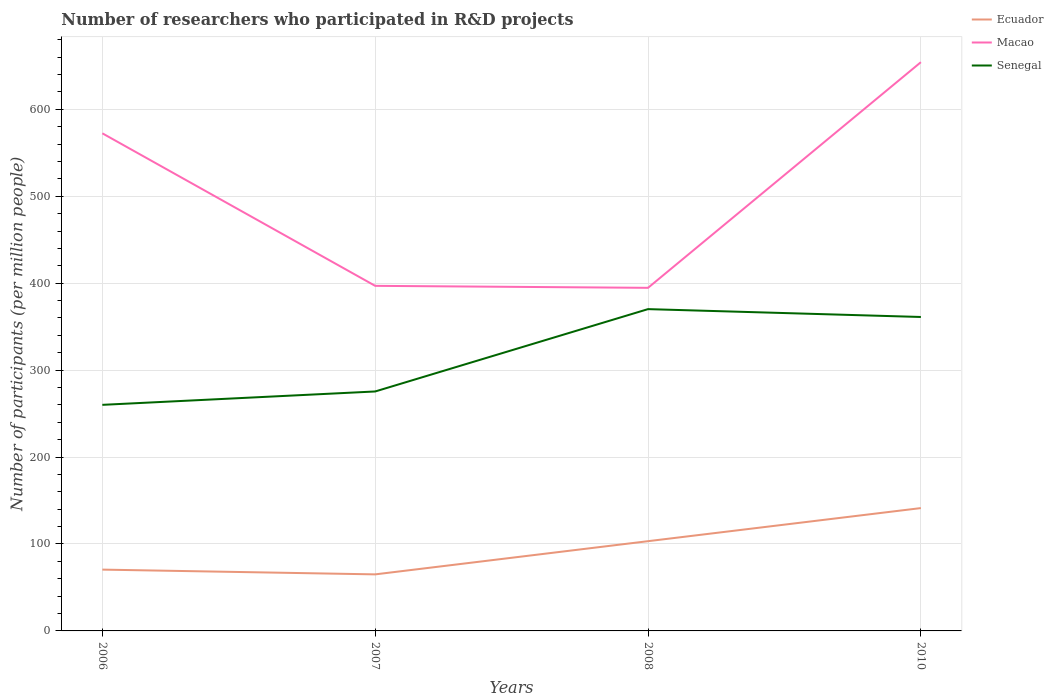How many different coloured lines are there?
Make the answer very short. 3. Across all years, what is the maximum number of researchers who participated in R&D projects in Macao?
Offer a very short reply. 394.66. What is the total number of researchers who participated in R&D projects in Ecuador in the graph?
Offer a very short reply. -70.78. What is the difference between the highest and the second highest number of researchers who participated in R&D projects in Macao?
Your answer should be compact. 259.56. How many lines are there?
Provide a succinct answer. 3. Are the values on the major ticks of Y-axis written in scientific E-notation?
Your response must be concise. No. Does the graph contain any zero values?
Offer a terse response. No. Does the graph contain grids?
Your response must be concise. Yes. Where does the legend appear in the graph?
Give a very brief answer. Top right. How many legend labels are there?
Your response must be concise. 3. How are the legend labels stacked?
Your answer should be compact. Vertical. What is the title of the graph?
Ensure brevity in your answer.  Number of researchers who participated in R&D projects. What is the label or title of the Y-axis?
Make the answer very short. Number of participants (per million people). What is the Number of participants (per million people) in Ecuador in 2006?
Make the answer very short. 70.52. What is the Number of participants (per million people) in Macao in 2006?
Your response must be concise. 572.41. What is the Number of participants (per million people) of Senegal in 2006?
Give a very brief answer. 260.05. What is the Number of participants (per million people) of Ecuador in 2007?
Offer a very short reply. 65.05. What is the Number of participants (per million people) in Macao in 2007?
Provide a short and direct response. 396.94. What is the Number of participants (per million people) in Senegal in 2007?
Your response must be concise. 275.44. What is the Number of participants (per million people) of Ecuador in 2008?
Ensure brevity in your answer.  103.23. What is the Number of participants (per million people) of Macao in 2008?
Offer a very short reply. 394.66. What is the Number of participants (per million people) of Senegal in 2008?
Your response must be concise. 370.16. What is the Number of participants (per million people) of Ecuador in 2010?
Your response must be concise. 141.3. What is the Number of participants (per million people) in Macao in 2010?
Your answer should be very brief. 654.21. What is the Number of participants (per million people) of Senegal in 2010?
Your answer should be very brief. 361.12. Across all years, what is the maximum Number of participants (per million people) of Ecuador?
Provide a succinct answer. 141.3. Across all years, what is the maximum Number of participants (per million people) of Macao?
Provide a short and direct response. 654.21. Across all years, what is the maximum Number of participants (per million people) of Senegal?
Provide a short and direct response. 370.16. Across all years, what is the minimum Number of participants (per million people) of Ecuador?
Ensure brevity in your answer.  65.05. Across all years, what is the minimum Number of participants (per million people) of Macao?
Offer a very short reply. 394.66. Across all years, what is the minimum Number of participants (per million people) of Senegal?
Ensure brevity in your answer.  260.05. What is the total Number of participants (per million people) of Ecuador in the graph?
Provide a short and direct response. 380.1. What is the total Number of participants (per million people) of Macao in the graph?
Provide a succinct answer. 2018.22. What is the total Number of participants (per million people) in Senegal in the graph?
Keep it short and to the point. 1266.77. What is the difference between the Number of participants (per million people) of Ecuador in 2006 and that in 2007?
Your answer should be compact. 5.48. What is the difference between the Number of participants (per million people) in Macao in 2006 and that in 2007?
Your answer should be compact. 175.47. What is the difference between the Number of participants (per million people) in Senegal in 2006 and that in 2007?
Provide a short and direct response. -15.39. What is the difference between the Number of participants (per million people) of Ecuador in 2006 and that in 2008?
Offer a very short reply. -32.71. What is the difference between the Number of participants (per million people) of Macao in 2006 and that in 2008?
Your answer should be very brief. 177.75. What is the difference between the Number of participants (per million people) in Senegal in 2006 and that in 2008?
Keep it short and to the point. -110.1. What is the difference between the Number of participants (per million people) of Ecuador in 2006 and that in 2010?
Give a very brief answer. -70.78. What is the difference between the Number of participants (per million people) of Macao in 2006 and that in 2010?
Make the answer very short. -81.81. What is the difference between the Number of participants (per million people) of Senegal in 2006 and that in 2010?
Keep it short and to the point. -101.07. What is the difference between the Number of participants (per million people) in Ecuador in 2007 and that in 2008?
Make the answer very short. -38.19. What is the difference between the Number of participants (per million people) in Macao in 2007 and that in 2008?
Provide a succinct answer. 2.28. What is the difference between the Number of participants (per million people) of Senegal in 2007 and that in 2008?
Offer a terse response. -94.71. What is the difference between the Number of participants (per million people) of Ecuador in 2007 and that in 2010?
Your answer should be very brief. -76.25. What is the difference between the Number of participants (per million people) in Macao in 2007 and that in 2010?
Offer a terse response. -257.27. What is the difference between the Number of participants (per million people) in Senegal in 2007 and that in 2010?
Your answer should be compact. -85.68. What is the difference between the Number of participants (per million people) in Ecuador in 2008 and that in 2010?
Provide a short and direct response. -38.07. What is the difference between the Number of participants (per million people) in Macao in 2008 and that in 2010?
Keep it short and to the point. -259.56. What is the difference between the Number of participants (per million people) of Senegal in 2008 and that in 2010?
Provide a succinct answer. 9.03. What is the difference between the Number of participants (per million people) in Ecuador in 2006 and the Number of participants (per million people) in Macao in 2007?
Offer a terse response. -326.42. What is the difference between the Number of participants (per million people) in Ecuador in 2006 and the Number of participants (per million people) in Senegal in 2007?
Ensure brevity in your answer.  -204.92. What is the difference between the Number of participants (per million people) in Macao in 2006 and the Number of participants (per million people) in Senegal in 2007?
Provide a succinct answer. 296.97. What is the difference between the Number of participants (per million people) in Ecuador in 2006 and the Number of participants (per million people) in Macao in 2008?
Make the answer very short. -324.14. What is the difference between the Number of participants (per million people) in Ecuador in 2006 and the Number of participants (per million people) in Senegal in 2008?
Give a very brief answer. -299.64. What is the difference between the Number of participants (per million people) in Macao in 2006 and the Number of participants (per million people) in Senegal in 2008?
Provide a short and direct response. 202.25. What is the difference between the Number of participants (per million people) of Ecuador in 2006 and the Number of participants (per million people) of Macao in 2010?
Your answer should be very brief. -583.69. What is the difference between the Number of participants (per million people) of Ecuador in 2006 and the Number of participants (per million people) of Senegal in 2010?
Your answer should be compact. -290.6. What is the difference between the Number of participants (per million people) of Macao in 2006 and the Number of participants (per million people) of Senegal in 2010?
Offer a terse response. 211.28. What is the difference between the Number of participants (per million people) of Ecuador in 2007 and the Number of participants (per million people) of Macao in 2008?
Provide a short and direct response. -329.61. What is the difference between the Number of participants (per million people) of Ecuador in 2007 and the Number of participants (per million people) of Senegal in 2008?
Your answer should be compact. -305.11. What is the difference between the Number of participants (per million people) in Macao in 2007 and the Number of participants (per million people) in Senegal in 2008?
Offer a very short reply. 26.78. What is the difference between the Number of participants (per million people) in Ecuador in 2007 and the Number of participants (per million people) in Macao in 2010?
Ensure brevity in your answer.  -589.17. What is the difference between the Number of participants (per million people) in Ecuador in 2007 and the Number of participants (per million people) in Senegal in 2010?
Provide a short and direct response. -296.08. What is the difference between the Number of participants (per million people) in Macao in 2007 and the Number of participants (per million people) in Senegal in 2010?
Your answer should be very brief. 35.82. What is the difference between the Number of participants (per million people) in Ecuador in 2008 and the Number of participants (per million people) in Macao in 2010?
Offer a very short reply. -550.98. What is the difference between the Number of participants (per million people) of Ecuador in 2008 and the Number of participants (per million people) of Senegal in 2010?
Make the answer very short. -257.89. What is the difference between the Number of participants (per million people) of Macao in 2008 and the Number of participants (per million people) of Senegal in 2010?
Provide a short and direct response. 33.54. What is the average Number of participants (per million people) in Ecuador per year?
Make the answer very short. 95.02. What is the average Number of participants (per million people) of Macao per year?
Keep it short and to the point. 504.56. What is the average Number of participants (per million people) of Senegal per year?
Keep it short and to the point. 316.69. In the year 2006, what is the difference between the Number of participants (per million people) in Ecuador and Number of participants (per million people) in Macao?
Offer a very short reply. -501.89. In the year 2006, what is the difference between the Number of participants (per million people) in Ecuador and Number of participants (per million people) in Senegal?
Your answer should be very brief. -189.53. In the year 2006, what is the difference between the Number of participants (per million people) in Macao and Number of participants (per million people) in Senegal?
Ensure brevity in your answer.  312.36. In the year 2007, what is the difference between the Number of participants (per million people) in Ecuador and Number of participants (per million people) in Macao?
Offer a terse response. -331.89. In the year 2007, what is the difference between the Number of participants (per million people) in Ecuador and Number of participants (per million people) in Senegal?
Provide a short and direct response. -210.4. In the year 2007, what is the difference between the Number of participants (per million people) of Macao and Number of participants (per million people) of Senegal?
Your response must be concise. 121.5. In the year 2008, what is the difference between the Number of participants (per million people) in Ecuador and Number of participants (per million people) in Macao?
Keep it short and to the point. -291.43. In the year 2008, what is the difference between the Number of participants (per million people) of Ecuador and Number of participants (per million people) of Senegal?
Your answer should be very brief. -266.92. In the year 2008, what is the difference between the Number of participants (per million people) in Macao and Number of participants (per million people) in Senegal?
Your answer should be compact. 24.5. In the year 2010, what is the difference between the Number of participants (per million people) in Ecuador and Number of participants (per million people) in Macao?
Offer a very short reply. -512.91. In the year 2010, what is the difference between the Number of participants (per million people) of Ecuador and Number of participants (per million people) of Senegal?
Give a very brief answer. -219.82. In the year 2010, what is the difference between the Number of participants (per million people) of Macao and Number of participants (per million people) of Senegal?
Ensure brevity in your answer.  293.09. What is the ratio of the Number of participants (per million people) in Ecuador in 2006 to that in 2007?
Provide a short and direct response. 1.08. What is the ratio of the Number of participants (per million people) of Macao in 2006 to that in 2007?
Give a very brief answer. 1.44. What is the ratio of the Number of participants (per million people) in Senegal in 2006 to that in 2007?
Offer a very short reply. 0.94. What is the ratio of the Number of participants (per million people) in Ecuador in 2006 to that in 2008?
Make the answer very short. 0.68. What is the ratio of the Number of participants (per million people) in Macao in 2006 to that in 2008?
Offer a terse response. 1.45. What is the ratio of the Number of participants (per million people) in Senegal in 2006 to that in 2008?
Keep it short and to the point. 0.7. What is the ratio of the Number of participants (per million people) in Ecuador in 2006 to that in 2010?
Your answer should be very brief. 0.5. What is the ratio of the Number of participants (per million people) in Senegal in 2006 to that in 2010?
Offer a terse response. 0.72. What is the ratio of the Number of participants (per million people) in Ecuador in 2007 to that in 2008?
Ensure brevity in your answer.  0.63. What is the ratio of the Number of participants (per million people) in Senegal in 2007 to that in 2008?
Your answer should be very brief. 0.74. What is the ratio of the Number of participants (per million people) of Ecuador in 2007 to that in 2010?
Ensure brevity in your answer.  0.46. What is the ratio of the Number of participants (per million people) of Macao in 2007 to that in 2010?
Your answer should be very brief. 0.61. What is the ratio of the Number of participants (per million people) of Senegal in 2007 to that in 2010?
Give a very brief answer. 0.76. What is the ratio of the Number of participants (per million people) in Ecuador in 2008 to that in 2010?
Give a very brief answer. 0.73. What is the ratio of the Number of participants (per million people) in Macao in 2008 to that in 2010?
Provide a succinct answer. 0.6. What is the difference between the highest and the second highest Number of participants (per million people) of Ecuador?
Keep it short and to the point. 38.07. What is the difference between the highest and the second highest Number of participants (per million people) in Macao?
Make the answer very short. 81.81. What is the difference between the highest and the second highest Number of participants (per million people) of Senegal?
Keep it short and to the point. 9.03. What is the difference between the highest and the lowest Number of participants (per million people) of Ecuador?
Give a very brief answer. 76.25. What is the difference between the highest and the lowest Number of participants (per million people) of Macao?
Ensure brevity in your answer.  259.56. What is the difference between the highest and the lowest Number of participants (per million people) in Senegal?
Keep it short and to the point. 110.1. 